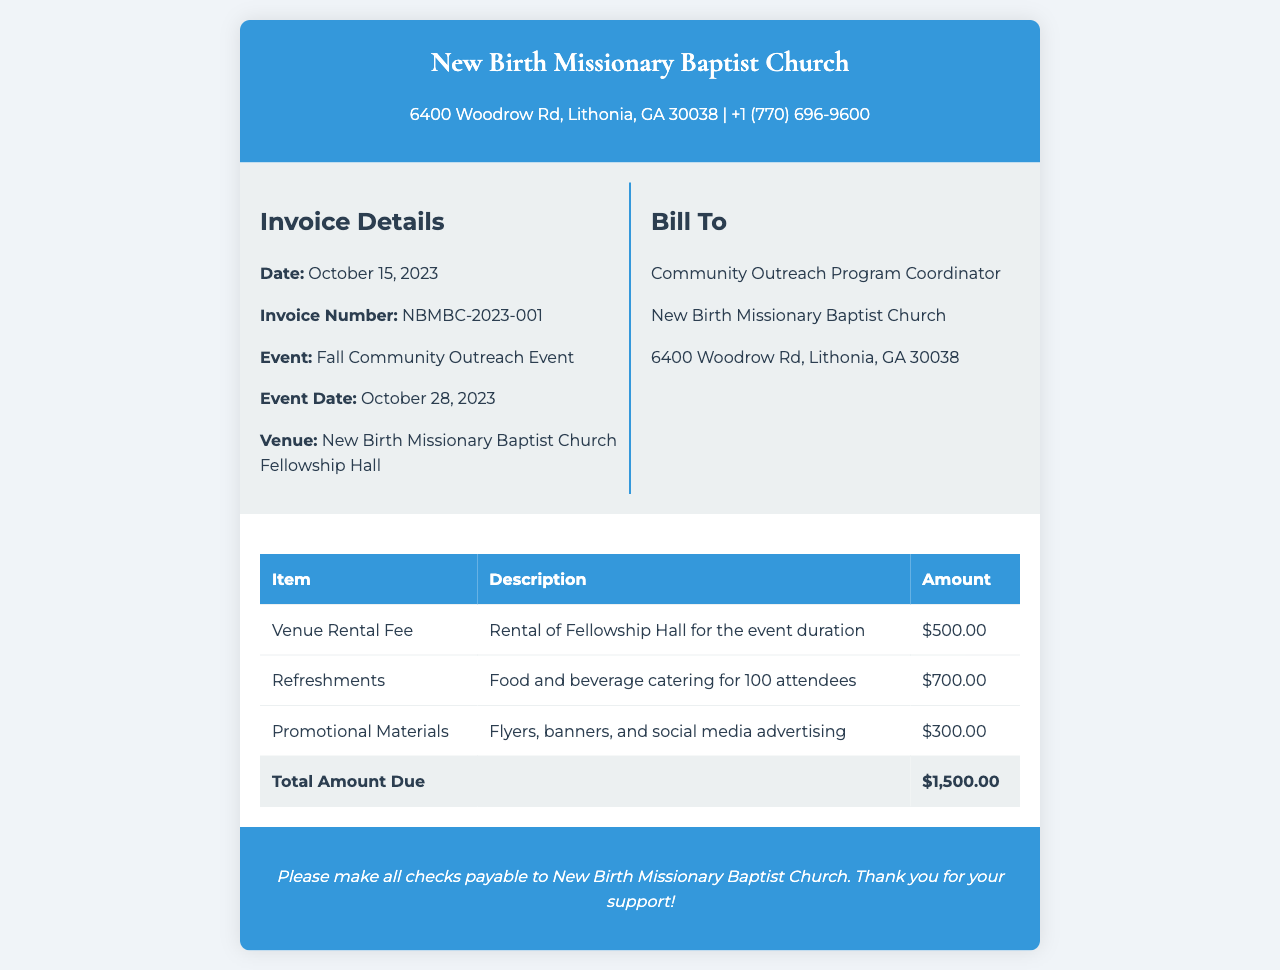What is the event date? The event date is specified in the document under "Event Date," which is October 28, 2023.
Answer: October 28, 2023 What is the total amount due? The total amount due is found at the end of the invoice table, calculated from all item charges, which totals $1,500.00.
Answer: $1,500.00 Who is the invoice addressed to? The "Bill To" section indicates that the invoice is addressed to the Community Outreach Program Coordinator.
Answer: Community Outreach Program Coordinator What is the venue for the event? The venue for the event is mentioned in the invoice, which states it is the New Birth Missionary Baptist Church Fellowship Hall.
Answer: New Birth Missionary Baptist Church Fellowship Hall How much is the venue rental fee? The venue rental fee is listed in the invoice table as $500.00.
Answer: $500.00 What types of promotional materials are included? The types of promotional materials are described in the invoice as flyers, banners, and social media advertising.
Answer: Flyers, banners, and social media advertising How many attendees are the refreshments catered for? The invoice specifies that the refreshments are catered for 100 attendees, which is mentioned in the description for refreshments.
Answer: 100 attendees What is included in the refreshments expense? It refers to food and beverage catering, described in the invoice under the refreshments item.
Answer: Food and beverage catering What is the invoice number? The invoice number is listed in the document as NBMBC-2023-001.
Answer: NBMBC-2023-001 